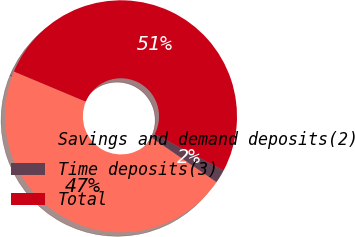Convert chart to OTSL. <chart><loc_0><loc_0><loc_500><loc_500><pie_chart><fcel>Savings and demand deposits(2)<fcel>Time deposits(3)<fcel>Total<nl><fcel>46.73%<fcel>1.87%<fcel>51.4%<nl></chart> 